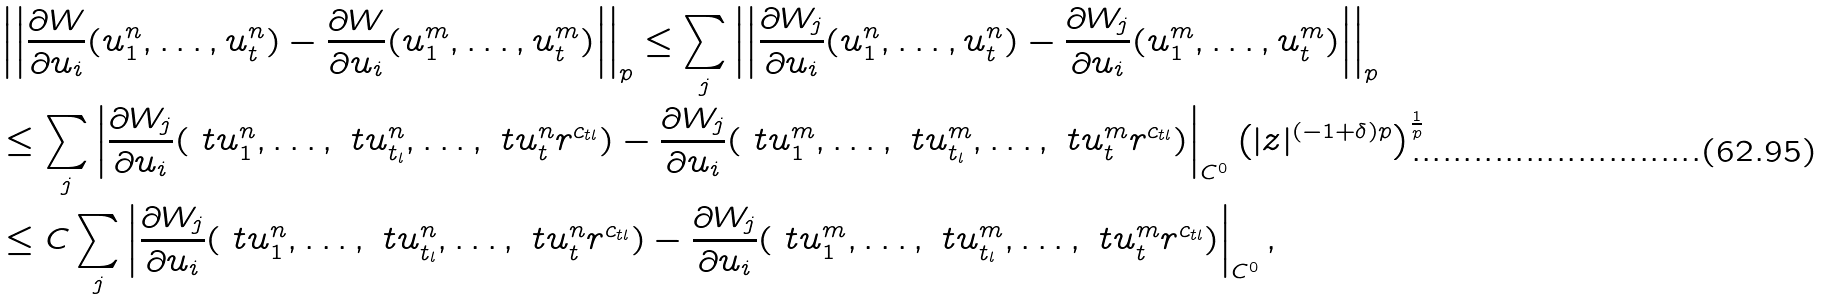<formula> <loc_0><loc_0><loc_500><loc_500>& \left | \left | \frac { \partial W } { \partial u _ { i } } ( u ^ { n } _ { 1 } , \dots , u ^ { n } _ { t } ) - \frac { \partial W } { \partial u _ { i } } ( u ^ { m } _ { 1 } , \dots , u ^ { m } _ { t } ) \right | \right | _ { p } \leq \sum _ { j } \left | \left | \frac { \partial W _ { j } } { \partial u _ { i } } ( u ^ { n } _ { 1 } , \dots , u ^ { n } _ { t } ) - \frac { \partial W _ { j } } { \partial u _ { i } } ( u ^ { m } _ { 1 } , \dots , u ^ { m } _ { t } ) \right | \right | _ { p } \\ & \leq \sum _ { j } \left | \frac { \partial W _ { j } } { \partial u _ { i } } ( \ t u ^ { n } _ { 1 } , \dots , \ t u ^ { n } _ { t _ { l } } , \dots , \ t u ^ { n } _ { t } r ^ { c _ { t l } } ) - \frac { \partial W _ { j } } { \partial u _ { i } } ( \ t u ^ { m } _ { 1 } , \dots , \ t u ^ { m } _ { t _ { l } } , \dots , \ t u ^ { m } _ { t } r ^ { c _ { t l } } ) \right | _ { C ^ { 0 } } \left ( | z | ^ { ( - 1 + \delta ) p } \right ) ^ { \frac { 1 } { p } } \\ & \leq C \sum _ { j } \left | \frac { \partial W _ { j } } { \partial u _ { i } } ( \ t u ^ { n } _ { 1 } , \dots , \ t u ^ { n } _ { t _ { l } } , \dots , \ t u ^ { n } _ { t } r ^ { c _ { t l } } ) - \frac { \partial W _ { j } } { \partial u _ { i } } ( \ t u ^ { m } _ { 1 } , \dots , \ t u ^ { m } _ { t _ { l } } , \dots , \ t u ^ { m } _ { t } r ^ { c _ { t l } } ) \right | _ { C ^ { 0 } } ,</formula> 